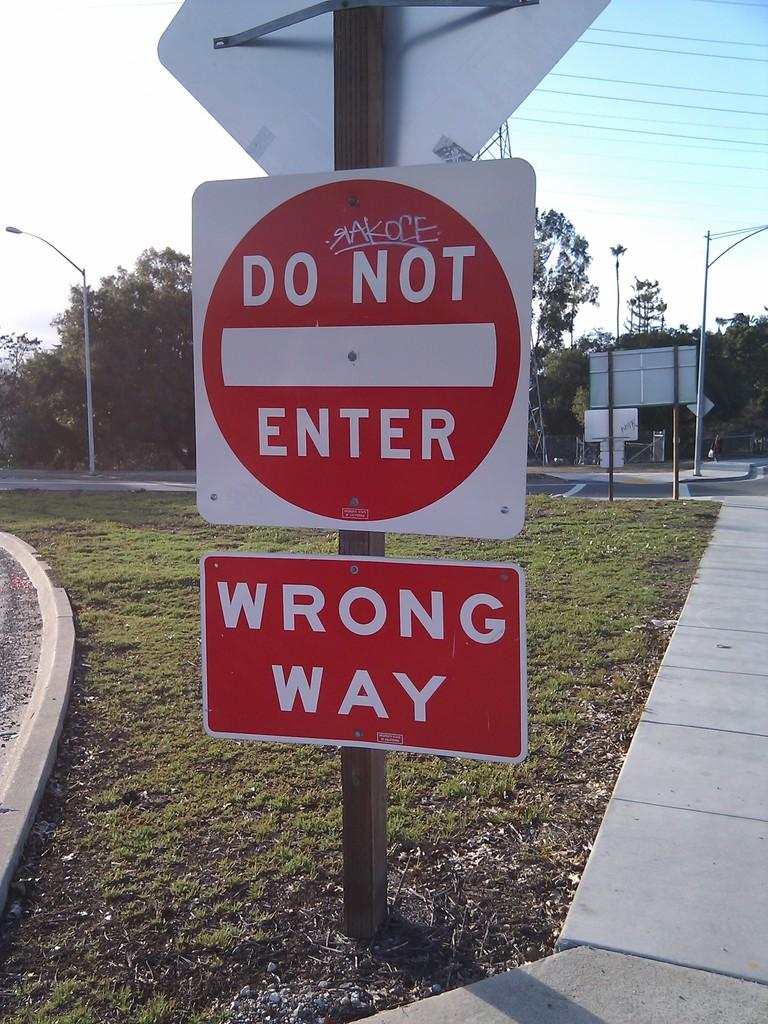What is attached to the pole in the image? There are boards attached to a pole in the image. What type of natural environment is visible in the image? There is grass visible in the image, and trees are also present. What other objects can be seen in the image? Cables and lights are visible in the image, as well as poles. What is visible in the background of the image? The sky is visible in the background of the image. What decision does the mother make in the image? There is no mother or decision-making process depicted in the image. How does the garden look in the image? There is no garden present in the image; it features boards attached to a pole, grass, trees, cables, lights, and poles. 